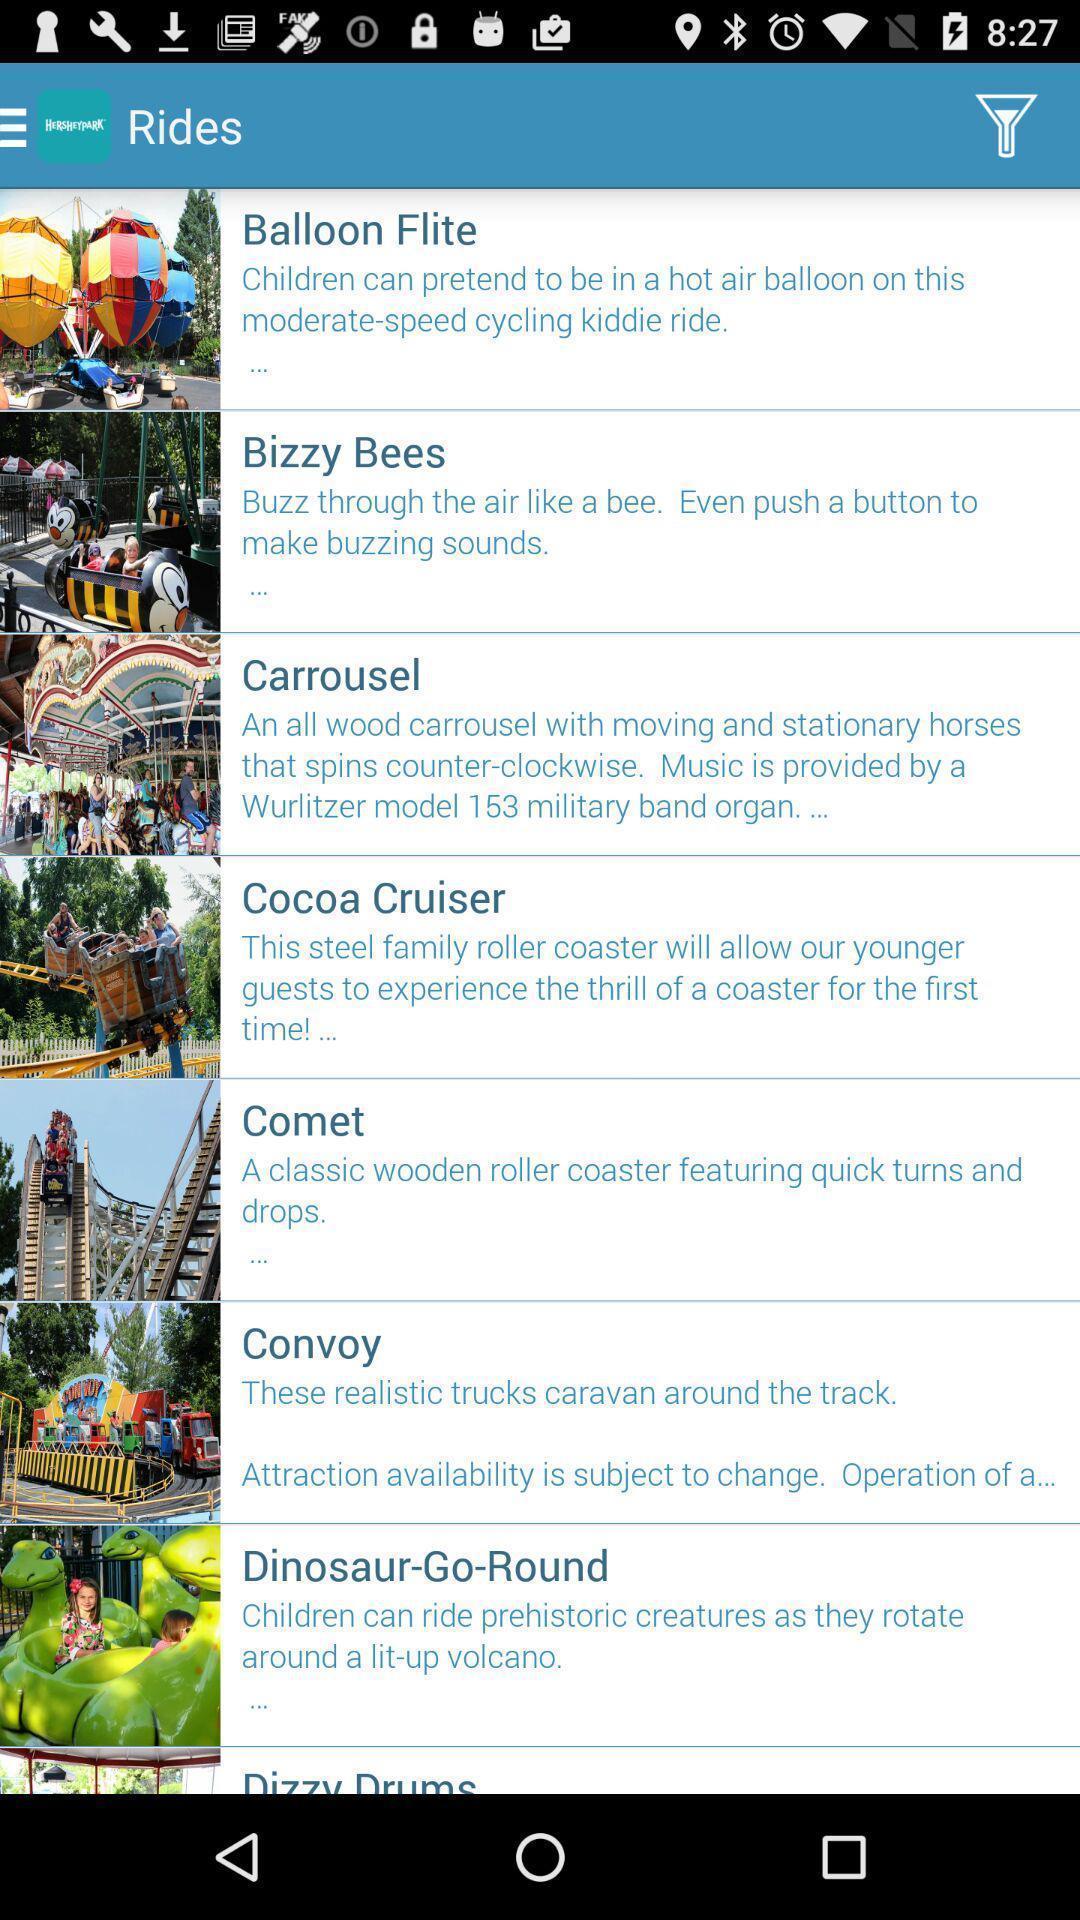Give me a narrative description of this picture. Screen shows different rides of an exhibition. 